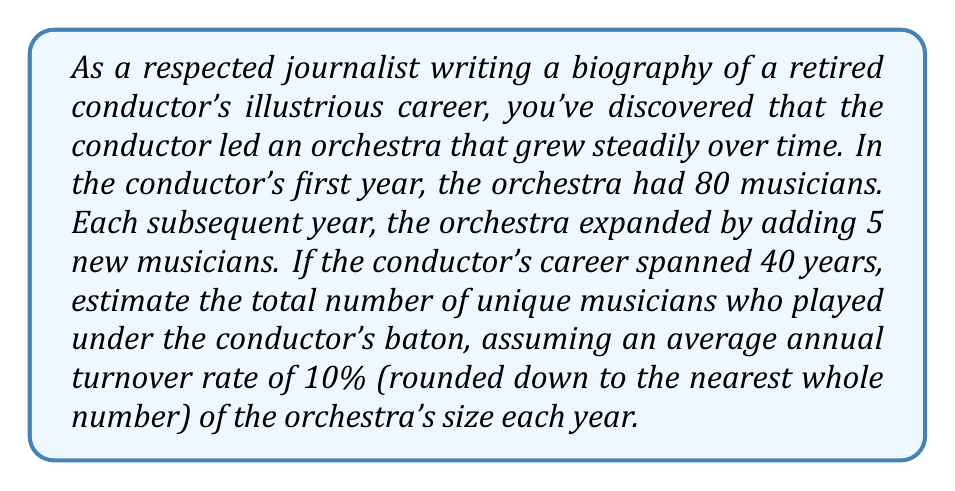Provide a solution to this math problem. To solve this problem, we need to use concepts from arithmetic sequences and series. Let's break it down step-by-step:

1) First, let's find the size of the orchestra in each year:
   - Year 1: 80 musicians
   - Year 2: 85 musicians
   - Year 3: 90 musicians
   ...and so on.

   This forms an arithmetic sequence with $a_1 = 80$ and $d = 5$.

2) The size of the orchestra in year $n$ is given by:
   $$a_n = a_1 + (n-1)d = 80 + (n-1)5 = 75 + 5n$$

3) The size of the orchestra in the final year (year 40) is:
   $$a_{40} = 75 + 5(40) = 275$$

4) Now, let's calculate the average orchestra size over the 40 years:
   $$S_{40} = \frac{40}{2}(a_1 + a_{40}) = \frac{40}{2}(80 + 275) = 7100$$
   $$\text{Average size} = \frac{S_{40}}{40} = 177.5$$

5) The average annual turnover is 10% of the average size:
   $$\text{Average annual turnover} = 0.1 \times 177.5 \approx 17$$

6) Over 40 years, the total turnover is:
   $$\text{Total turnover} = 17 \times 40 = 680$$

7) To get the total number of unique musicians, we add the final orchestra size to the total turnover:
   $$\text{Total unique musicians} = 275 + 680 = 955$$
Answer: The estimated total number of unique musicians who played under the conductor's baton over the 40-year career is approximately 955. 